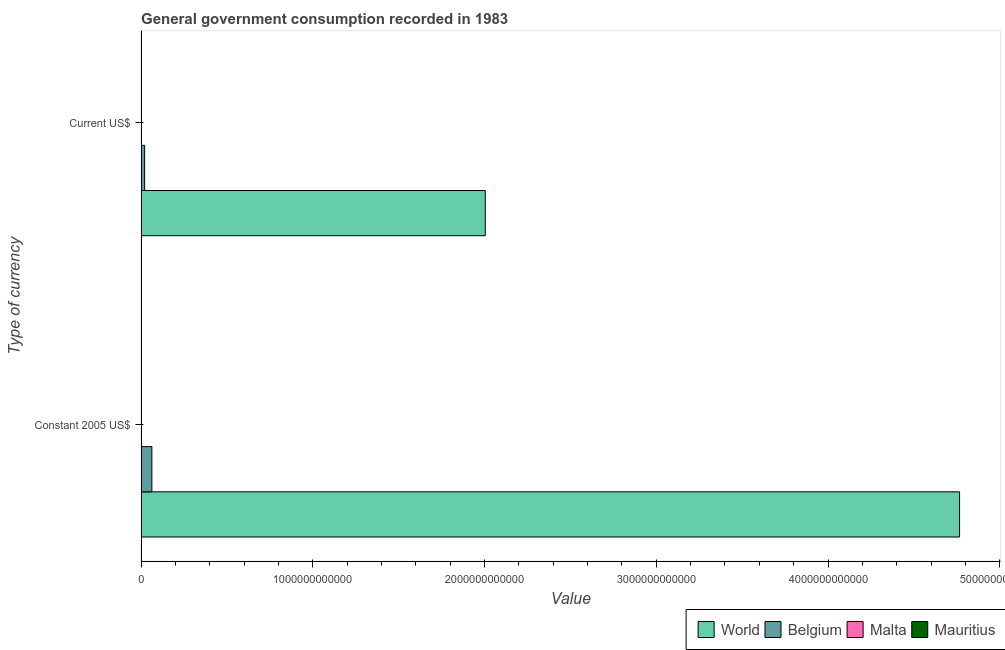How many bars are there on the 2nd tick from the top?
Offer a very short reply. 4. What is the label of the 2nd group of bars from the top?
Provide a succinct answer. Constant 2005 US$. What is the value consumed in constant 2005 us$ in World?
Give a very brief answer. 4.77e+12. Across all countries, what is the maximum value consumed in constant 2005 us$?
Keep it short and to the point. 4.77e+12. Across all countries, what is the minimum value consumed in current us$?
Keep it short and to the point. 1.46e+08. In which country was the value consumed in constant 2005 us$ minimum?
Ensure brevity in your answer.  Malta. What is the total value consumed in current us$ in the graph?
Your answer should be compact. 2.02e+12. What is the difference between the value consumed in current us$ in Malta and that in World?
Provide a succinct answer. -2.00e+12. What is the difference between the value consumed in constant 2005 us$ in Mauritius and the value consumed in current us$ in Malta?
Make the answer very short. 1.81e+08. What is the average value consumed in current us$ per country?
Give a very brief answer. 5.06e+11. What is the difference between the value consumed in current us$ and value consumed in constant 2005 us$ in Belgium?
Offer a terse response. -4.21e+1. In how many countries, is the value consumed in current us$ greater than 1800000000000 ?
Give a very brief answer. 1. What is the ratio of the value consumed in current us$ in Malta to that in Belgium?
Provide a short and direct response. 0.01. Is the value consumed in current us$ in Malta less than that in World?
Ensure brevity in your answer.  Yes. In how many countries, is the value consumed in constant 2005 us$ greater than the average value consumed in constant 2005 us$ taken over all countries?
Offer a terse response. 1. What does the 1st bar from the bottom in Constant 2005 US$ represents?
Provide a short and direct response. World. How many countries are there in the graph?
Make the answer very short. 4. What is the difference between two consecutive major ticks on the X-axis?
Offer a very short reply. 1.00e+12. Does the graph contain any zero values?
Offer a terse response. No. How many legend labels are there?
Provide a short and direct response. 4. What is the title of the graph?
Make the answer very short. General government consumption recorded in 1983. What is the label or title of the X-axis?
Ensure brevity in your answer.  Value. What is the label or title of the Y-axis?
Provide a succinct answer. Type of currency. What is the Value in World in Constant 2005 US$?
Your answer should be very brief. 4.77e+12. What is the Value in Belgium in Constant 2005 US$?
Provide a short and direct response. 6.24e+1. What is the Value of Malta in Constant 2005 US$?
Offer a terse response. 3.47e+08. What is the Value in Mauritius in Constant 2005 US$?
Give a very brief answer. 3.75e+08. What is the Value in World in Current US$?
Your answer should be compact. 2.00e+12. What is the Value in Belgium in Current US$?
Make the answer very short. 2.04e+1. What is the Value in Malta in Current US$?
Give a very brief answer. 1.94e+08. What is the Value in Mauritius in Current US$?
Your answer should be compact. 1.46e+08. Across all Type of currency, what is the maximum Value in World?
Provide a succinct answer. 4.77e+12. Across all Type of currency, what is the maximum Value of Belgium?
Ensure brevity in your answer.  6.24e+1. Across all Type of currency, what is the maximum Value of Malta?
Offer a very short reply. 3.47e+08. Across all Type of currency, what is the maximum Value in Mauritius?
Your answer should be very brief. 3.75e+08. Across all Type of currency, what is the minimum Value of World?
Offer a very short reply. 2.00e+12. Across all Type of currency, what is the minimum Value in Belgium?
Offer a terse response. 2.04e+1. Across all Type of currency, what is the minimum Value of Malta?
Provide a short and direct response. 1.94e+08. Across all Type of currency, what is the minimum Value of Mauritius?
Your answer should be very brief. 1.46e+08. What is the total Value of World in the graph?
Keep it short and to the point. 6.77e+12. What is the total Value in Belgium in the graph?
Make the answer very short. 8.28e+1. What is the total Value in Malta in the graph?
Offer a terse response. 5.40e+08. What is the total Value of Mauritius in the graph?
Ensure brevity in your answer.  5.21e+08. What is the difference between the Value of World in Constant 2005 US$ and that in Current US$?
Offer a terse response. 2.76e+12. What is the difference between the Value in Belgium in Constant 2005 US$ and that in Current US$?
Offer a very short reply. 4.21e+1. What is the difference between the Value in Malta in Constant 2005 US$ and that in Current US$?
Provide a succinct answer. 1.53e+08. What is the difference between the Value in Mauritius in Constant 2005 US$ and that in Current US$?
Your response must be concise. 2.29e+08. What is the difference between the Value of World in Constant 2005 US$ and the Value of Belgium in Current US$?
Your answer should be very brief. 4.75e+12. What is the difference between the Value in World in Constant 2005 US$ and the Value in Malta in Current US$?
Your answer should be very brief. 4.77e+12. What is the difference between the Value in World in Constant 2005 US$ and the Value in Mauritius in Current US$?
Your answer should be compact. 4.77e+12. What is the difference between the Value of Belgium in Constant 2005 US$ and the Value of Malta in Current US$?
Give a very brief answer. 6.23e+1. What is the difference between the Value in Belgium in Constant 2005 US$ and the Value in Mauritius in Current US$?
Provide a short and direct response. 6.23e+1. What is the difference between the Value in Malta in Constant 2005 US$ and the Value in Mauritius in Current US$?
Make the answer very short. 2.01e+08. What is the average Value of World per Type of currency?
Make the answer very short. 3.39e+12. What is the average Value of Belgium per Type of currency?
Give a very brief answer. 4.14e+1. What is the average Value of Malta per Type of currency?
Ensure brevity in your answer.  2.70e+08. What is the average Value in Mauritius per Type of currency?
Your answer should be compact. 2.60e+08. What is the difference between the Value in World and Value in Belgium in Constant 2005 US$?
Give a very brief answer. 4.70e+12. What is the difference between the Value in World and Value in Malta in Constant 2005 US$?
Provide a succinct answer. 4.77e+12. What is the difference between the Value of World and Value of Mauritius in Constant 2005 US$?
Provide a succinct answer. 4.77e+12. What is the difference between the Value in Belgium and Value in Malta in Constant 2005 US$?
Provide a short and direct response. 6.21e+1. What is the difference between the Value in Belgium and Value in Mauritius in Constant 2005 US$?
Ensure brevity in your answer.  6.21e+1. What is the difference between the Value of Malta and Value of Mauritius in Constant 2005 US$?
Your answer should be very brief. -2.81e+07. What is the difference between the Value in World and Value in Belgium in Current US$?
Offer a terse response. 1.98e+12. What is the difference between the Value of World and Value of Malta in Current US$?
Offer a very short reply. 2.00e+12. What is the difference between the Value of World and Value of Mauritius in Current US$?
Make the answer very short. 2.00e+12. What is the difference between the Value in Belgium and Value in Malta in Current US$?
Your answer should be very brief. 2.02e+1. What is the difference between the Value in Belgium and Value in Mauritius in Current US$?
Keep it short and to the point. 2.02e+1. What is the difference between the Value of Malta and Value of Mauritius in Current US$?
Your answer should be very brief. 4.78e+07. What is the ratio of the Value of World in Constant 2005 US$ to that in Current US$?
Provide a short and direct response. 2.38. What is the ratio of the Value of Belgium in Constant 2005 US$ to that in Current US$?
Give a very brief answer. 3.07. What is the ratio of the Value in Malta in Constant 2005 US$ to that in Current US$?
Your answer should be very brief. 1.79. What is the ratio of the Value in Mauritius in Constant 2005 US$ to that in Current US$?
Your answer should be compact. 2.57. What is the difference between the highest and the second highest Value of World?
Your response must be concise. 2.76e+12. What is the difference between the highest and the second highest Value of Belgium?
Ensure brevity in your answer.  4.21e+1. What is the difference between the highest and the second highest Value of Malta?
Give a very brief answer. 1.53e+08. What is the difference between the highest and the second highest Value in Mauritius?
Your answer should be very brief. 2.29e+08. What is the difference between the highest and the lowest Value in World?
Your answer should be very brief. 2.76e+12. What is the difference between the highest and the lowest Value in Belgium?
Provide a short and direct response. 4.21e+1. What is the difference between the highest and the lowest Value of Malta?
Provide a short and direct response. 1.53e+08. What is the difference between the highest and the lowest Value in Mauritius?
Your answer should be very brief. 2.29e+08. 